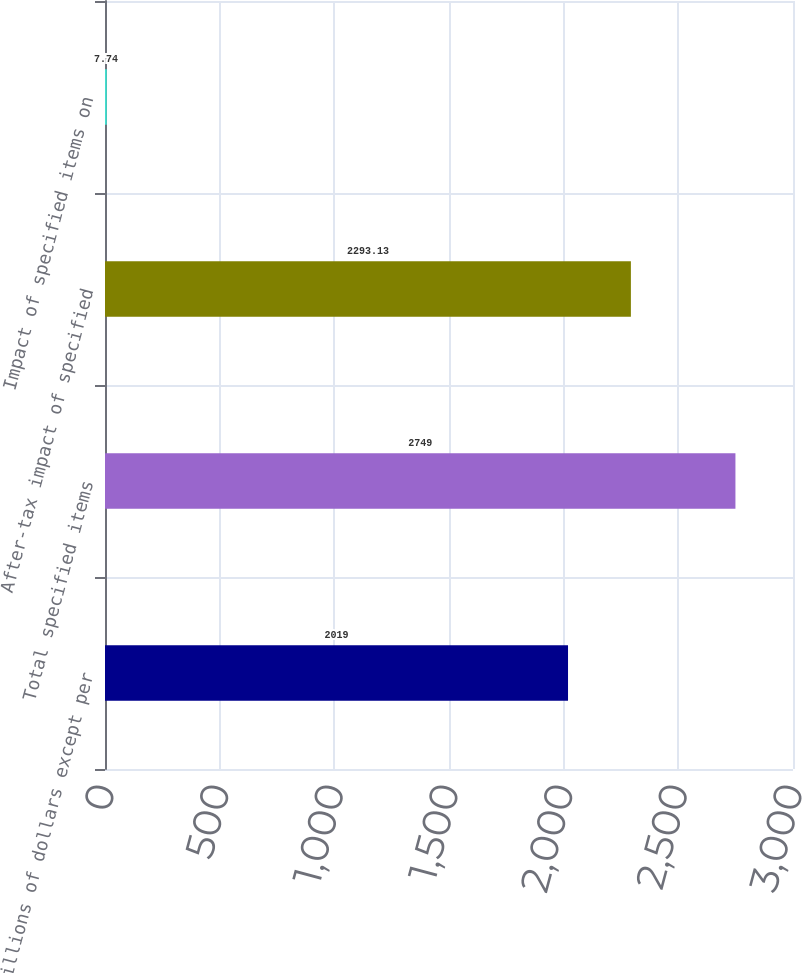Convert chart. <chart><loc_0><loc_0><loc_500><loc_500><bar_chart><fcel>Millions of dollars except per<fcel>Total specified items<fcel>After-tax impact of specified<fcel>Impact of specified items on<nl><fcel>2019<fcel>2749<fcel>2293.13<fcel>7.74<nl></chart> 